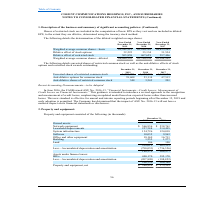From Cogent Communications Group's financial document, What are the respective number of basic weighted average common shares in 2018 and 2019? The document shows two values: 45,280,161 and 45,542,315. From the document: "7 Weighted average common shares—basic 45,542,315 45,280,161 44,855,263 Dilutive effect of stock options 32,222 33,134 31,534 Dilutive effect of restr..." Also, What are the respective number of basic weighted average common shares in 2017 and 2018? The document shows two values: 44,855,263 and 45,280,161. From the document: "7 Weighted average common shares—basic 45,542,315 45,280,161 44,855,263 Dilutive effect of stock options 32,222 33,134 31,534 Dilutive effect of restr..." Also, What are the respective number of dilutive effect of stock options in 2018 and 2019? The document shows two values: 33,134 and 32,222. From the document: "4,855,263 Dilutive effect of stock options 32,222 33,134 31,534 Dilutive effect of restricted stock 505,858 467,659 297,406 Weighted average common sh..." Also, can you calculate: What is the average number of basic weighted average common shares in 2018 and 2019? To answer this question, I need to perform calculations using the financial data. The calculation is: (45,542,315 + 45,280,161)/2, which equals 45411238. This is based on the information: "19 2018 2017 Weighted average common shares—basic 45,542,315 45,280,161 44,855,263 Dilutive effect of stock options 32,222 33,134 31,534 Dilutive effect of rest 7 Weighted average common shares—basic ..." The key data points involved are: 45,280,161, 45,542,315. Also, can you calculate: What is the average number of basic weighted average common shares in 2017 and 2018? To answer this question, I need to perform calculations using the financial data. The calculation is: (44,855,263 + 45,280,161)/2 , which equals 45067712. This is based on the information: "7 Weighted average common shares—basic 45,542,315 45,280,161 44,855,263 Dilutive effect of stock options 32,222 33,134 31,534 Dilutive effect of restricted stoc average common shares—basic 45,542,315 ..." The key data points involved are: 44,855,263, 45,280,161. Also, can you calculate: What is the average dilutive effect of stock options in 2018 and 2019? To answer this question, I need to perform calculations using the financial data. The calculation is: (33,134 + 32,222)/2 , which equals 32678. This is based on the information: "4,855,263 Dilutive effect of stock options 32,222 33,134 31,534 Dilutive effect of restricted stock 505,858 467,659 297,406 Weighted average common shares—d 0,161 44,855,263 Dilutive effect of stock o..." The key data points involved are: 32,222, 33,134. 